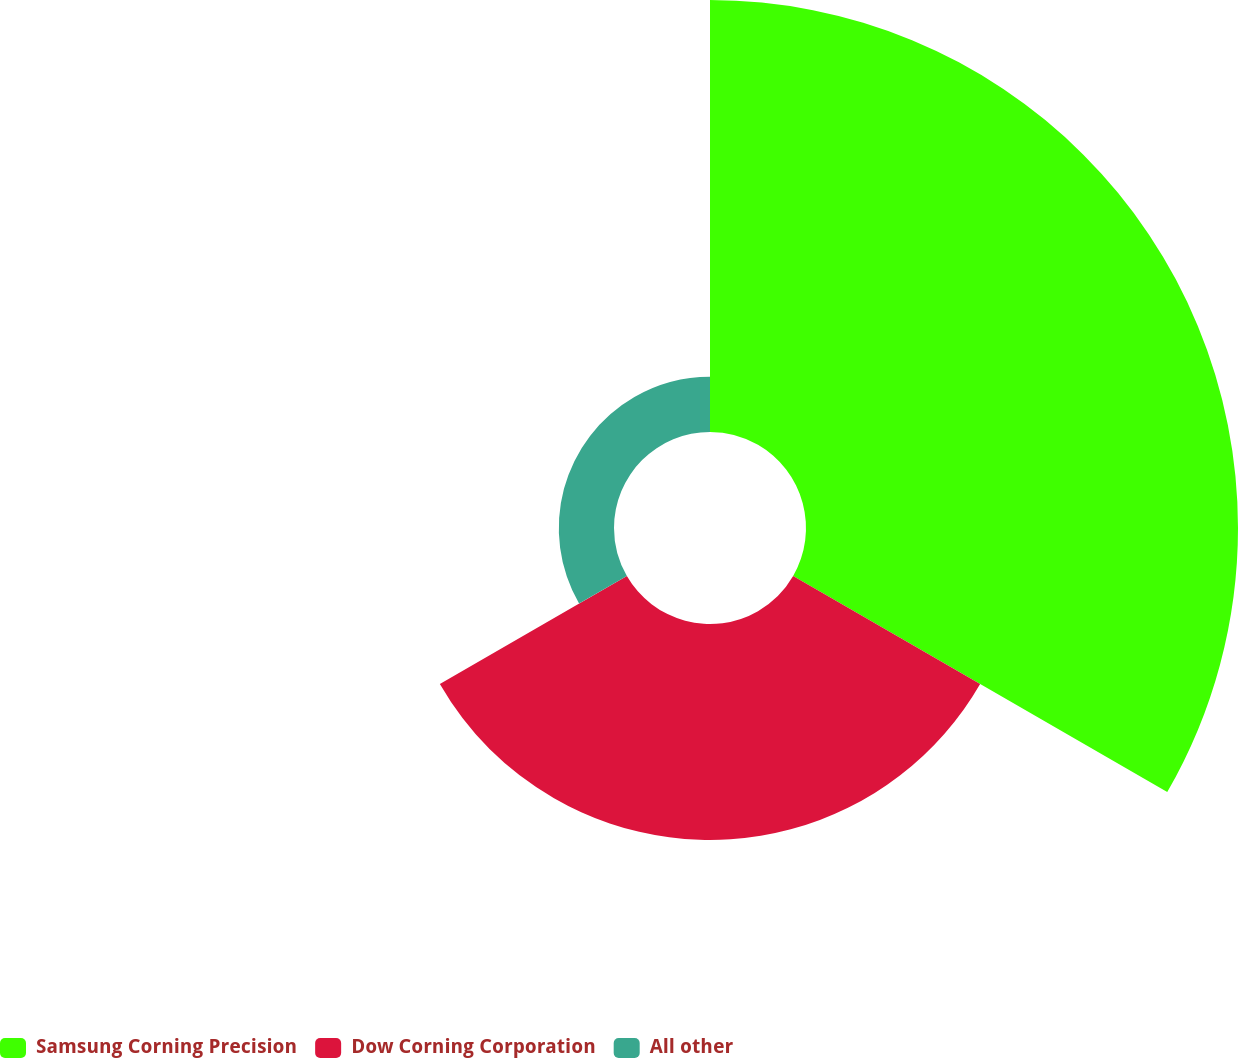Convert chart to OTSL. <chart><loc_0><loc_0><loc_500><loc_500><pie_chart><fcel>Samsung Corning Precision<fcel>Dow Corning Corporation<fcel>All other<nl><fcel>61.44%<fcel>30.71%<fcel>7.85%<nl></chart> 